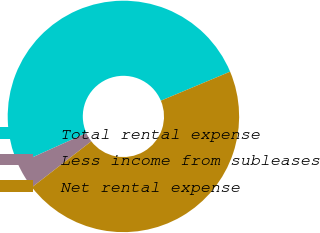<chart> <loc_0><loc_0><loc_500><loc_500><pie_chart><fcel>Total rental expense<fcel>Less income from subleases<fcel>Net rental expense<nl><fcel>50.41%<fcel>3.76%<fcel>45.83%<nl></chart> 